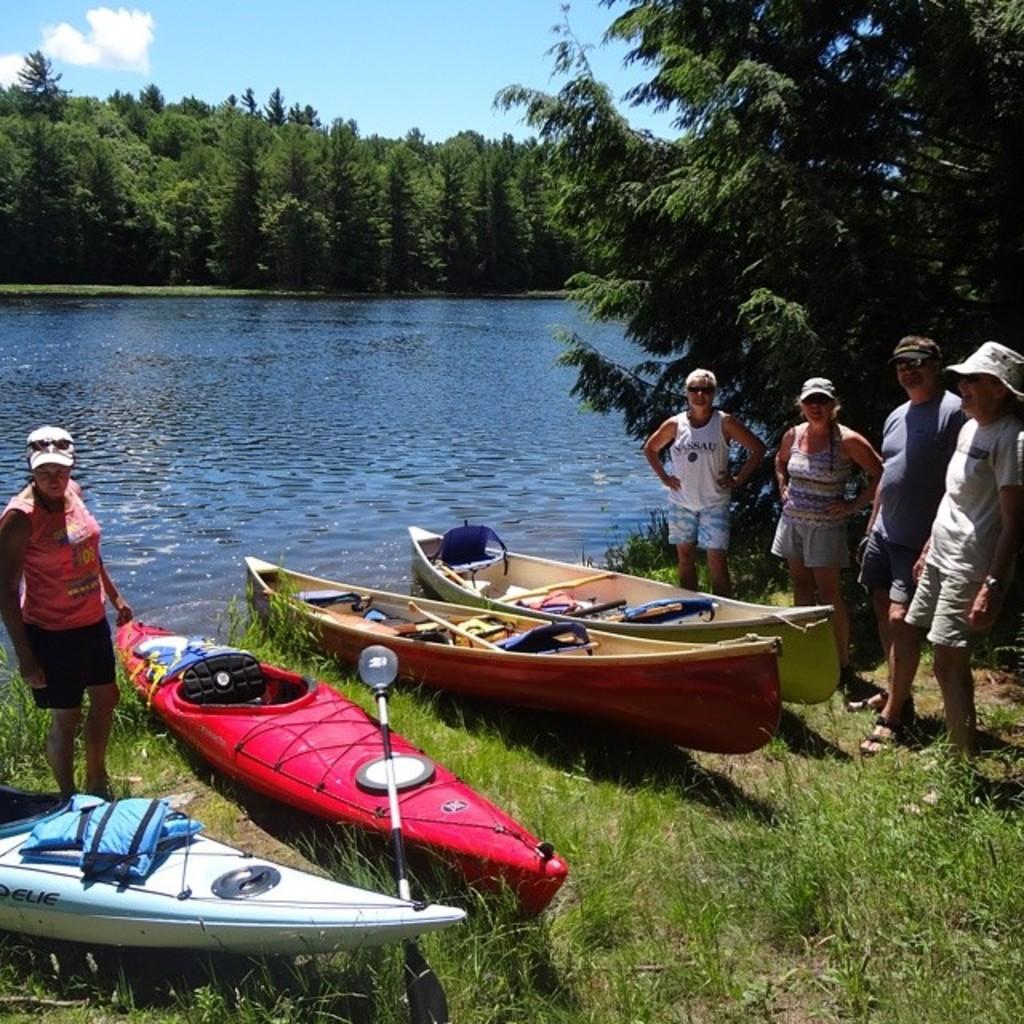Could you give a brief overview of what you see in this image? In this image I can see on the left side a woman is looking at these boots, she wore pink color top, black color shorts. On the right side a group of people are standing and smiling, they wore t-shirts, shorts. In the middle it looks like a river. At the back side there are trees, at the top there is the sky. 